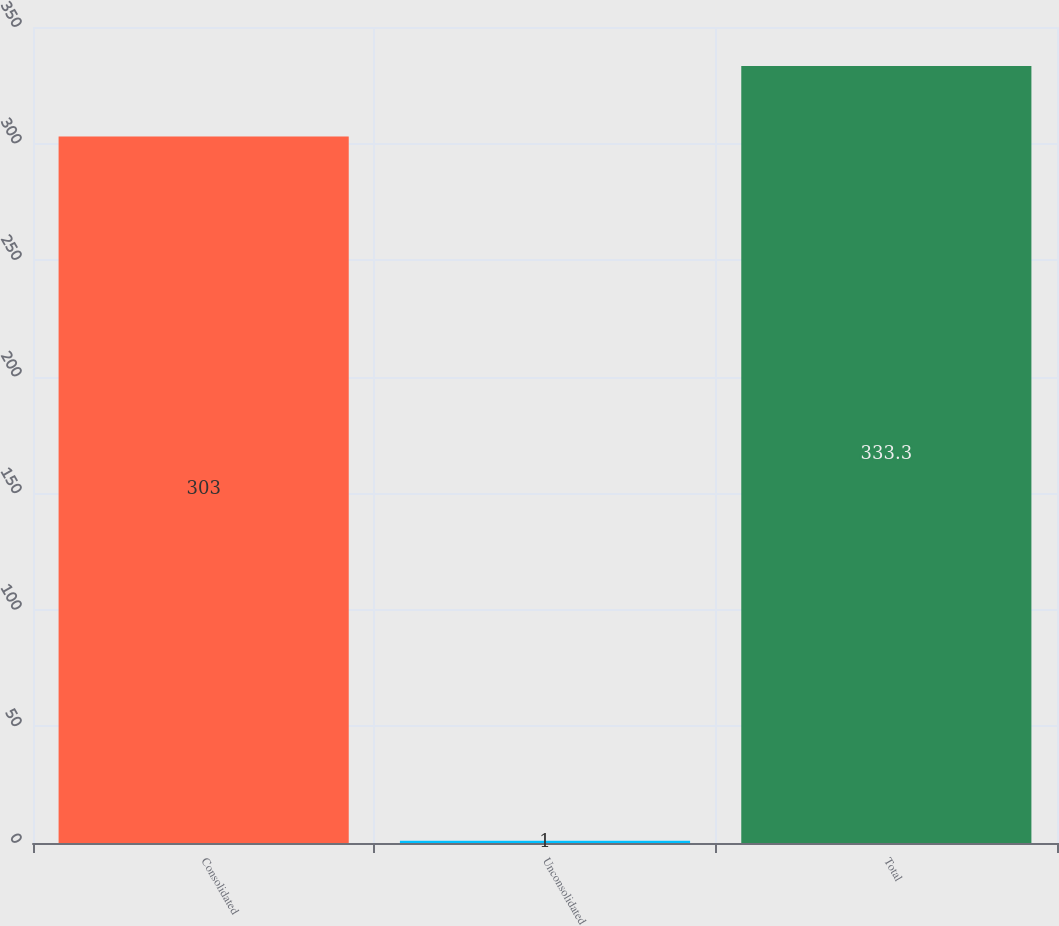Convert chart. <chart><loc_0><loc_0><loc_500><loc_500><bar_chart><fcel>Consolidated<fcel>Unconsolidated<fcel>Total<nl><fcel>303<fcel>1<fcel>333.3<nl></chart> 